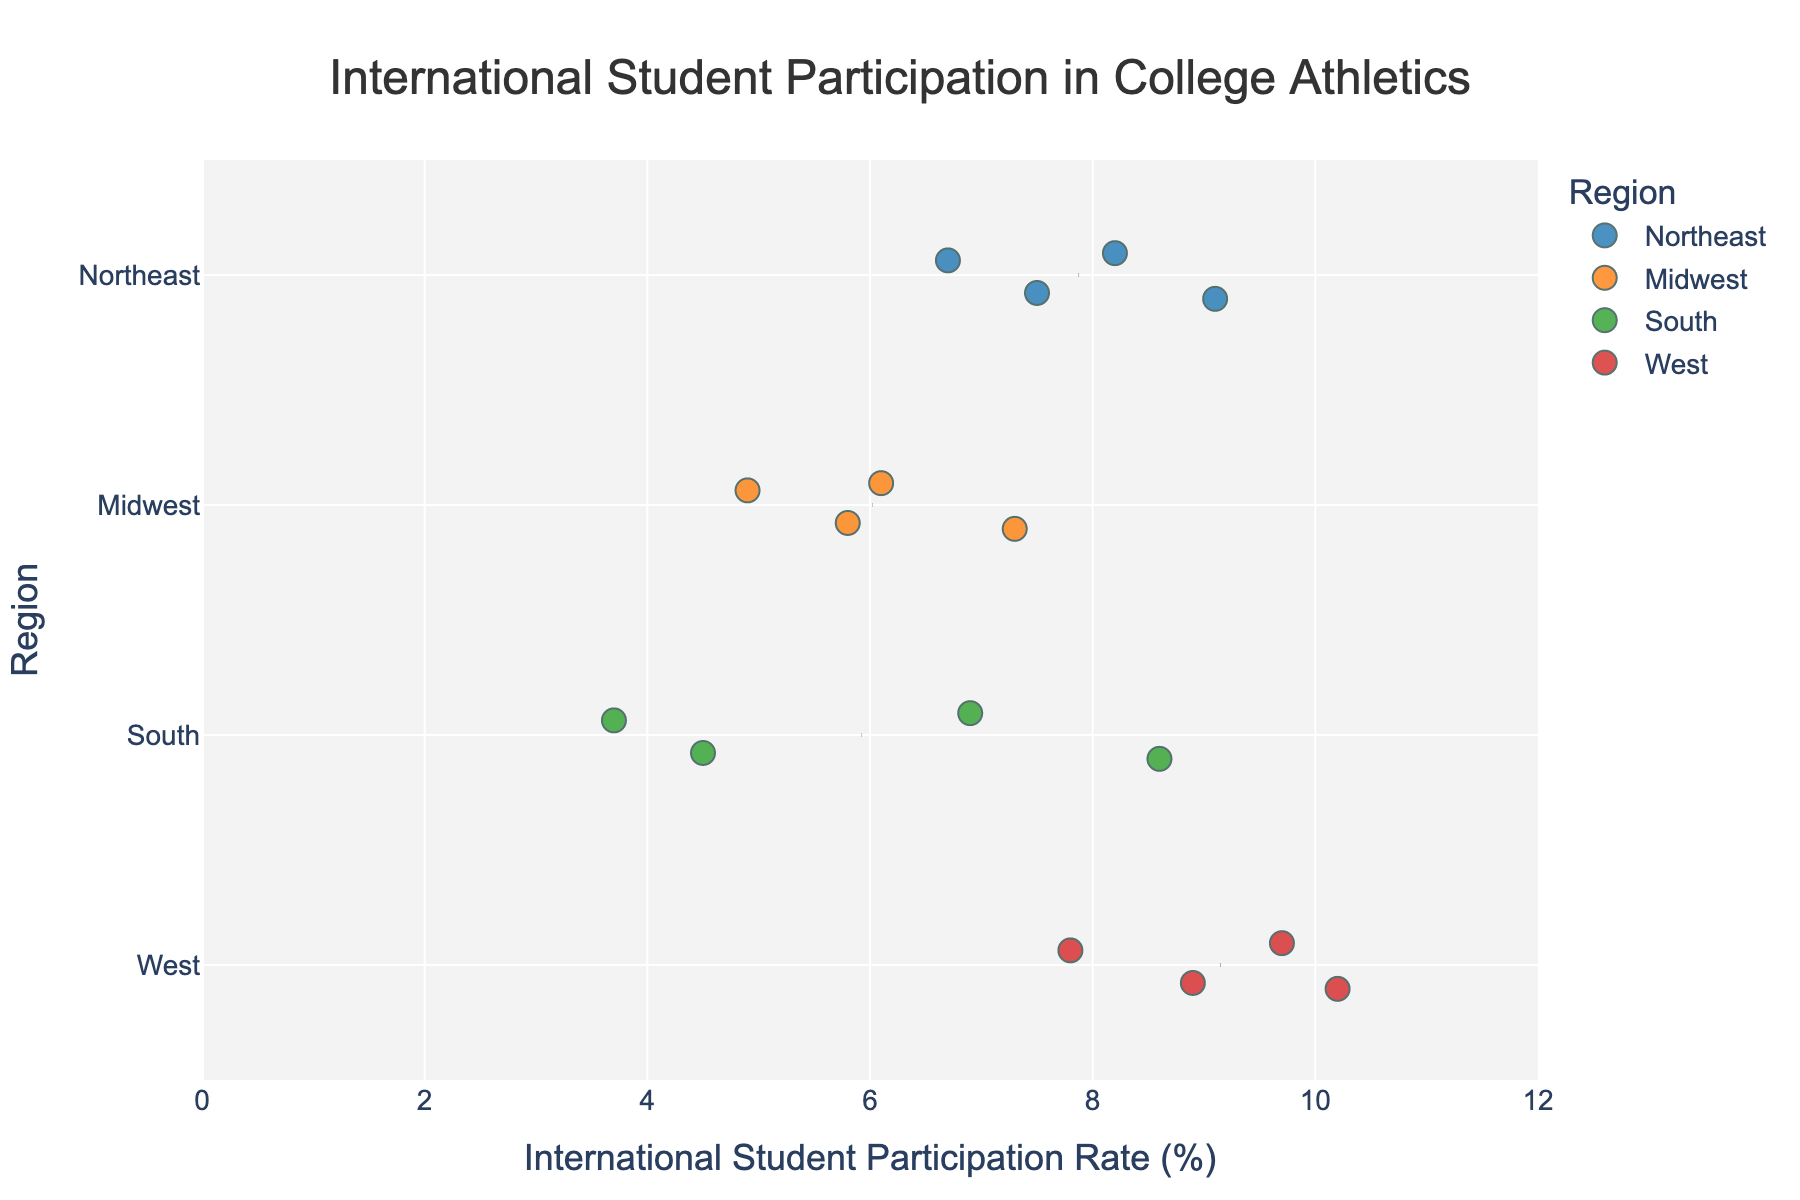What is the title of the figure? The title is usually located at the top of the figure in a larger font size. In this case, the title of the figure is: "International Student Participation in College Athletics."
Answer: International Student Participation in College Athletics Which region has the highest participation rate for international students? To answer this, we look for the data point with the highest value in the "International Student Participation Rate" axis. Stanford University in the West region has the highest rate, which is 10.2%.
Answer: West What is the lowest participation rate in the South region? To find this, examine the points in the South region and identify the one with the lowest value on the "International Student Participation Rate" axis, which is at the University of Florida with a rate of 3.7%.
Answer: 3.7% Which university has the highest international student participation rate in the Northeast region? By focusing on the Northeast region and comparing the values, you can see that Syracuse University has the highest participation rate of 9.1%.
Answer: Syracuse University What is the mean participation rate for the Midwest region? The calculation involves averaging the data points for the Midwest region. The participation rates are 5.8, 4.9, 7.3, and 6.1. The sum is 5.8 + 4.9 + 7.3 + 6.1 = 24.1, and the mean is 24.1 / 4 = 6.025.
Answer: 6.025 How do the participation rates in the West region compare to those in the Northeast region? By comparing the spread and central tendencies of both regions, on average, the West region has higher participation rates with Stanford (10.2%) and UC Berkeley (9.7%) compared to the Northeast's higher-value universities like Syracuse (9.1%) and Harvard (8.2%).
Answer: West region has higher rates Is there a noticeable difference in the participation rates between the South and Midwest regions? By examining the spread and specific values, the South region has a broader range from 3.7% to 8.6%, while the Midwest region ranges from 4.9% to 7.3%. The Midwest appears to have more clustered rates around a mean of 6.025, whereas the South has more variability.
Answer: Yes, different spread Which university in the West region has a participation rate close to the average for that region? The average participation rate for the West region is calculated by averaging 10.2, 9.7, 7.8, and 8.9. The sum is 36.6, and the average is 36.6 / 4 = 9.15. The University of Southern California, with a rate of 8.9%, is close to this average.
Answer: University of Southern California What is the range of participation rates for the universities in the Northeast region? To find the range, subtract the smallest value from the largest value in the Northeast region, which are Syracuse University at 9.1% and Boston College at 6.7%. So, the range is 9.1 - 6.7 = 2.4%.
Answer: 2.4% 